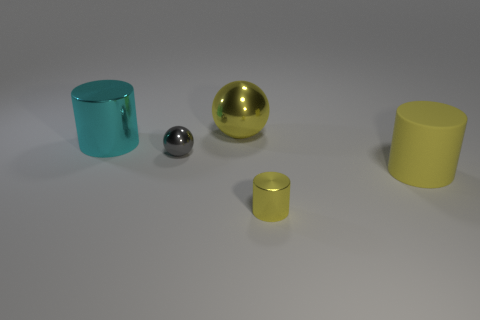There is a cylinder that is in front of the rubber thing; what color is it?
Give a very brief answer. Yellow. There is a yellow metallic object right of the yellow ball; are there any big metallic balls that are in front of it?
Your answer should be compact. No. Is the shape of the large matte object the same as the large metallic object that is to the left of the gray ball?
Provide a succinct answer. Yes. There is a shiny thing that is both to the right of the big cyan shiny object and left of the big shiny ball; how big is it?
Your answer should be compact. Small. Are there any tiny cubes that have the same material as the big sphere?
Make the answer very short. No. What size is the metallic ball that is the same color as the big rubber thing?
Keep it short and to the point. Large. What material is the big yellow object that is in front of the cylinder that is on the left side of the large yellow ball?
Keep it short and to the point. Rubber. What number of large shiny spheres are the same color as the small sphere?
Your answer should be compact. 0. There is a cyan cylinder that is the same material as the yellow sphere; what size is it?
Provide a short and direct response. Large. There is a large metallic object that is right of the large cyan object; what shape is it?
Make the answer very short. Sphere. 